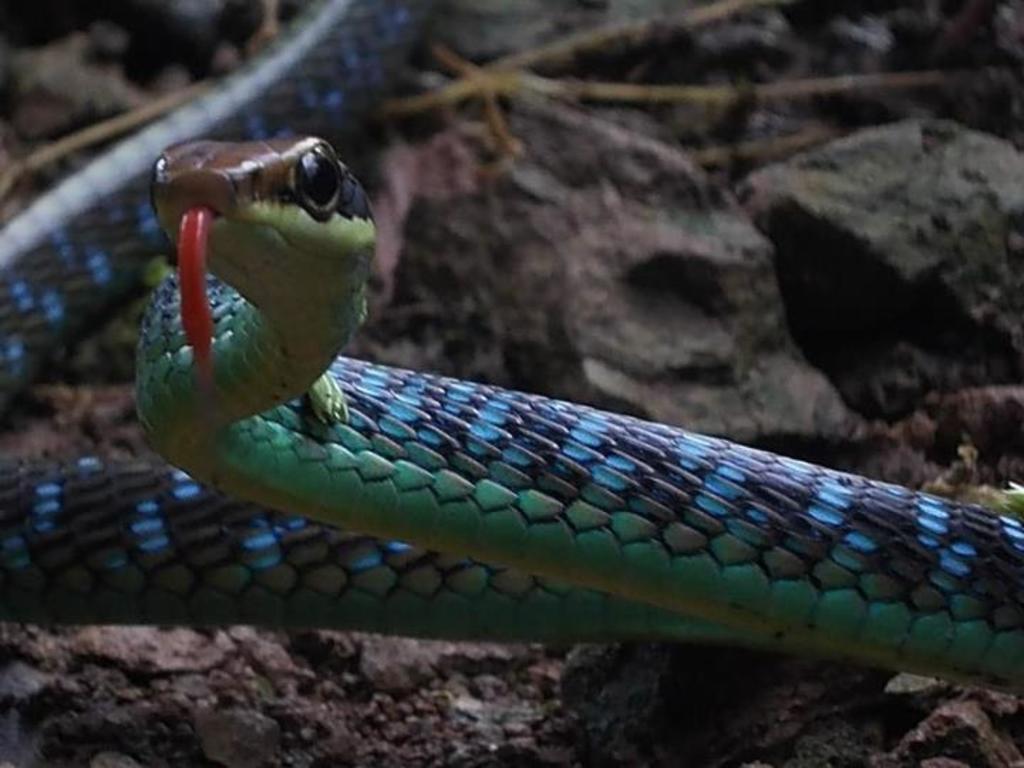Describe this image in one or two sentences. In this picture there is a snake in the center of the image and there are stones in the background area of the image. 